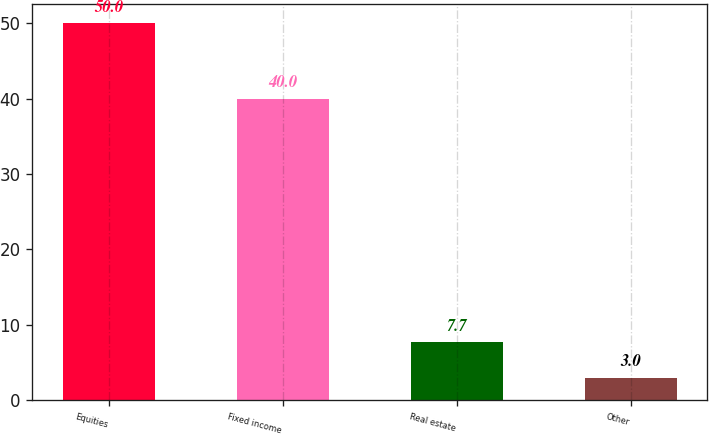<chart> <loc_0><loc_0><loc_500><loc_500><bar_chart><fcel>Equities<fcel>Fixed income<fcel>Real estate<fcel>Other<nl><fcel>50<fcel>40<fcel>7.7<fcel>3<nl></chart> 